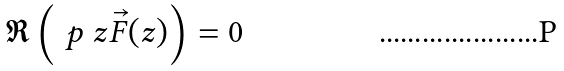<formula> <loc_0><loc_0><loc_500><loc_500>\Re \left ( \ p { \ z } \vec { F } ( z ) \right ) = 0</formula> 